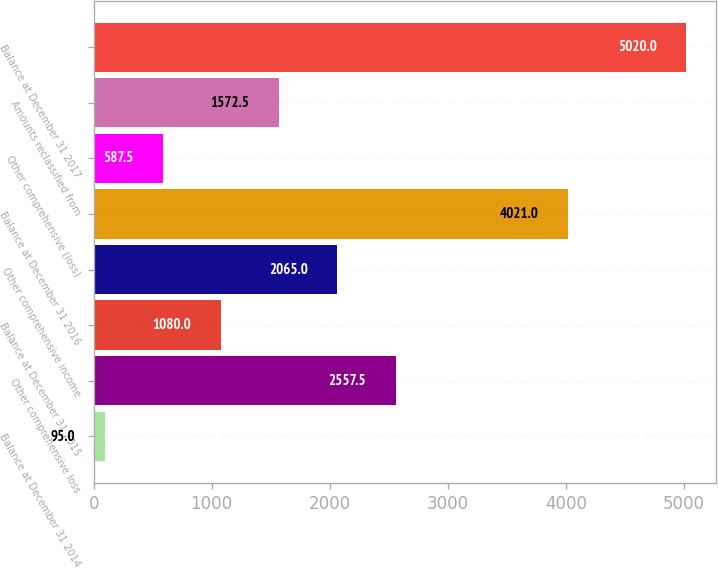<chart> <loc_0><loc_0><loc_500><loc_500><bar_chart><fcel>Balance at December 31 2014<fcel>Other comprehensive loss<fcel>Balance at December 31 2015<fcel>Other comprehensive income<fcel>Balance at December 31 2016<fcel>Other comprehensive (loss)<fcel>Amounts reclassified from<fcel>Balance at December 31 2017<nl><fcel>95<fcel>2557.5<fcel>1080<fcel>2065<fcel>4021<fcel>587.5<fcel>1572.5<fcel>5020<nl></chart> 